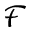<formula> <loc_0><loc_0><loc_500><loc_500>\mathcal { F }</formula> 